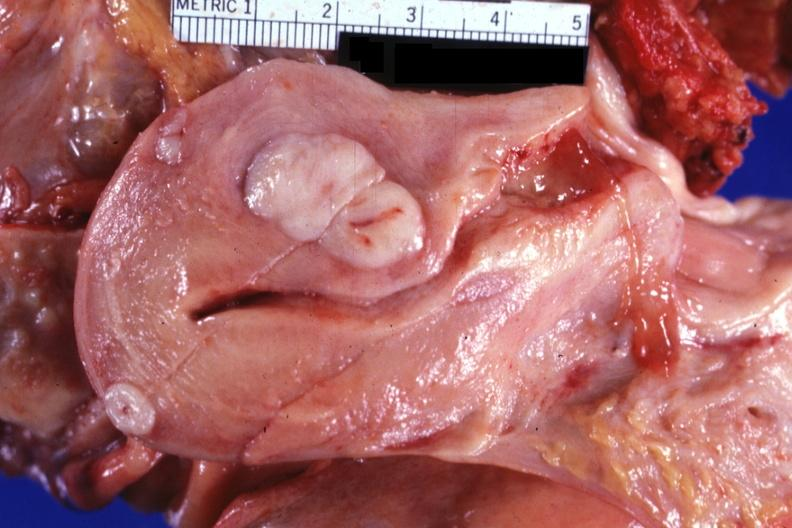does angiogram saphenous vein bypass graft show sectioned uterus shown close-up with typical small myomas very good?
Answer the question using a single word or phrase. No 